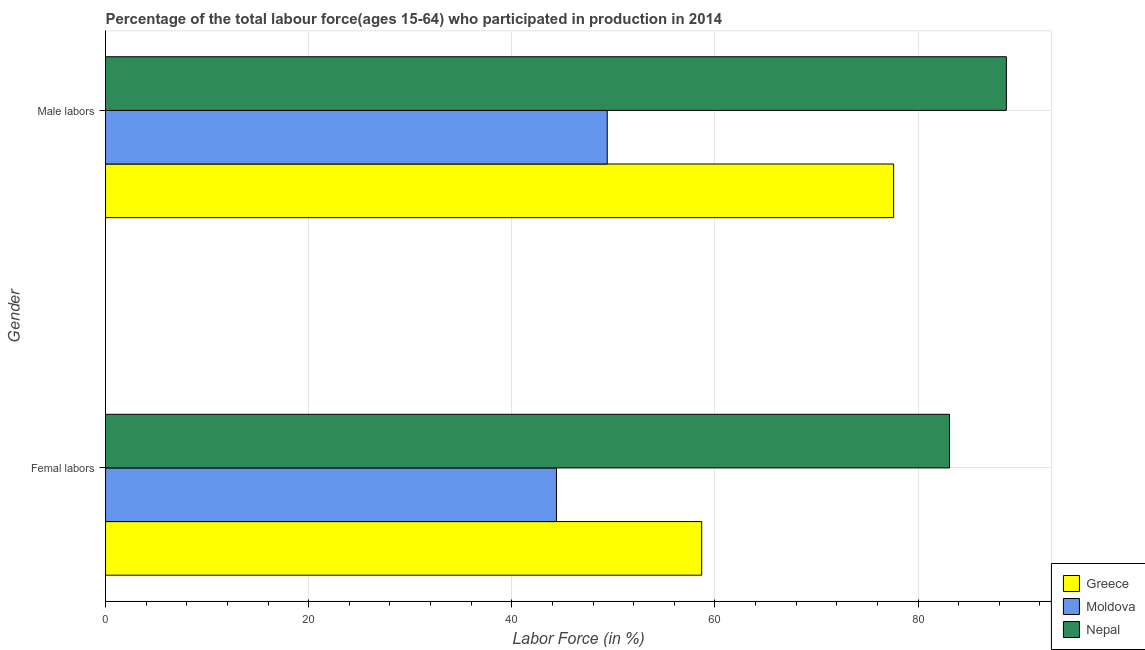How many different coloured bars are there?
Your answer should be very brief. 3. How many groups of bars are there?
Your answer should be compact. 2. Are the number of bars on each tick of the Y-axis equal?
Provide a succinct answer. Yes. How many bars are there on the 1st tick from the bottom?
Make the answer very short. 3. What is the label of the 1st group of bars from the top?
Your answer should be compact. Male labors. What is the percentage of female labor force in Moldova?
Offer a very short reply. 44.4. Across all countries, what is the maximum percentage of female labor force?
Offer a terse response. 83.1. Across all countries, what is the minimum percentage of male labour force?
Keep it short and to the point. 49.4. In which country was the percentage of female labor force maximum?
Keep it short and to the point. Nepal. In which country was the percentage of female labor force minimum?
Your response must be concise. Moldova. What is the total percentage of male labour force in the graph?
Your answer should be compact. 215.7. What is the difference between the percentage of female labor force in Nepal and that in Moldova?
Keep it short and to the point. 38.7. What is the difference between the percentage of female labor force in Nepal and the percentage of male labour force in Greece?
Your answer should be very brief. 5.5. What is the average percentage of female labor force per country?
Make the answer very short. 62.07. In how many countries, is the percentage of female labor force greater than 64 %?
Your answer should be very brief. 1. What is the ratio of the percentage of female labor force in Greece to that in Nepal?
Provide a succinct answer. 0.71. In how many countries, is the percentage of male labour force greater than the average percentage of male labour force taken over all countries?
Give a very brief answer. 2. What does the 1st bar from the top in Male labors represents?
Offer a terse response. Nepal. Does the graph contain grids?
Your answer should be compact. Yes. Where does the legend appear in the graph?
Provide a succinct answer. Bottom right. What is the title of the graph?
Keep it short and to the point. Percentage of the total labour force(ages 15-64) who participated in production in 2014. Does "Lebanon" appear as one of the legend labels in the graph?
Provide a succinct answer. No. What is the label or title of the Y-axis?
Offer a very short reply. Gender. What is the Labor Force (in %) of Greece in Femal labors?
Offer a terse response. 58.7. What is the Labor Force (in %) of Moldova in Femal labors?
Provide a short and direct response. 44.4. What is the Labor Force (in %) of Nepal in Femal labors?
Your answer should be very brief. 83.1. What is the Labor Force (in %) of Greece in Male labors?
Offer a very short reply. 77.6. What is the Labor Force (in %) of Moldova in Male labors?
Ensure brevity in your answer.  49.4. What is the Labor Force (in %) in Nepal in Male labors?
Keep it short and to the point. 88.7. Across all Gender, what is the maximum Labor Force (in %) of Greece?
Provide a succinct answer. 77.6. Across all Gender, what is the maximum Labor Force (in %) of Moldova?
Keep it short and to the point. 49.4. Across all Gender, what is the maximum Labor Force (in %) in Nepal?
Your answer should be compact. 88.7. Across all Gender, what is the minimum Labor Force (in %) in Greece?
Provide a short and direct response. 58.7. Across all Gender, what is the minimum Labor Force (in %) in Moldova?
Offer a terse response. 44.4. Across all Gender, what is the minimum Labor Force (in %) of Nepal?
Keep it short and to the point. 83.1. What is the total Labor Force (in %) of Greece in the graph?
Make the answer very short. 136.3. What is the total Labor Force (in %) of Moldova in the graph?
Offer a very short reply. 93.8. What is the total Labor Force (in %) of Nepal in the graph?
Offer a very short reply. 171.8. What is the difference between the Labor Force (in %) in Greece in Femal labors and that in Male labors?
Your answer should be very brief. -18.9. What is the difference between the Labor Force (in %) of Nepal in Femal labors and that in Male labors?
Keep it short and to the point. -5.6. What is the difference between the Labor Force (in %) in Greece in Femal labors and the Labor Force (in %) in Moldova in Male labors?
Offer a terse response. 9.3. What is the difference between the Labor Force (in %) of Moldova in Femal labors and the Labor Force (in %) of Nepal in Male labors?
Provide a succinct answer. -44.3. What is the average Labor Force (in %) of Greece per Gender?
Make the answer very short. 68.15. What is the average Labor Force (in %) of Moldova per Gender?
Offer a terse response. 46.9. What is the average Labor Force (in %) in Nepal per Gender?
Provide a short and direct response. 85.9. What is the difference between the Labor Force (in %) in Greece and Labor Force (in %) in Nepal in Femal labors?
Your answer should be very brief. -24.4. What is the difference between the Labor Force (in %) of Moldova and Labor Force (in %) of Nepal in Femal labors?
Make the answer very short. -38.7. What is the difference between the Labor Force (in %) of Greece and Labor Force (in %) of Moldova in Male labors?
Keep it short and to the point. 28.2. What is the difference between the Labor Force (in %) of Greece and Labor Force (in %) of Nepal in Male labors?
Ensure brevity in your answer.  -11.1. What is the difference between the Labor Force (in %) of Moldova and Labor Force (in %) of Nepal in Male labors?
Keep it short and to the point. -39.3. What is the ratio of the Labor Force (in %) in Greece in Femal labors to that in Male labors?
Ensure brevity in your answer.  0.76. What is the ratio of the Labor Force (in %) in Moldova in Femal labors to that in Male labors?
Provide a succinct answer. 0.9. What is the ratio of the Labor Force (in %) of Nepal in Femal labors to that in Male labors?
Give a very brief answer. 0.94. What is the difference between the highest and the second highest Labor Force (in %) in Moldova?
Your response must be concise. 5. What is the difference between the highest and the second highest Labor Force (in %) of Nepal?
Offer a very short reply. 5.6. 